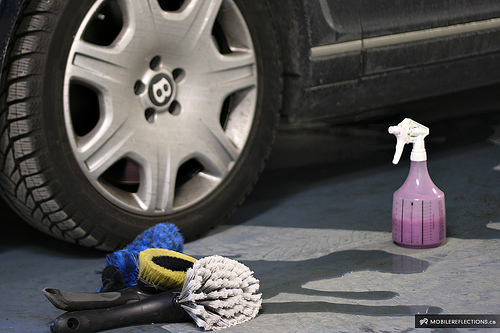<image>
Is there a wheel behind the bottle? Yes. From this viewpoint, the wheel is positioned behind the bottle, with the bottle partially or fully occluding the wheel. 